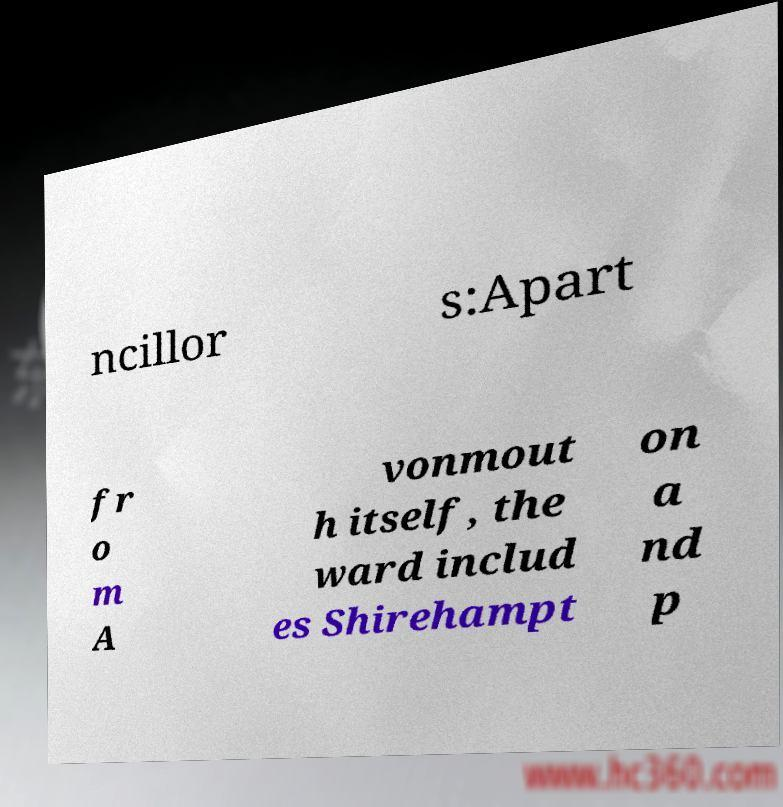There's text embedded in this image that I need extracted. Can you transcribe it verbatim? ncillor s:Apart fr o m A vonmout h itself, the ward includ es Shirehampt on a nd p 